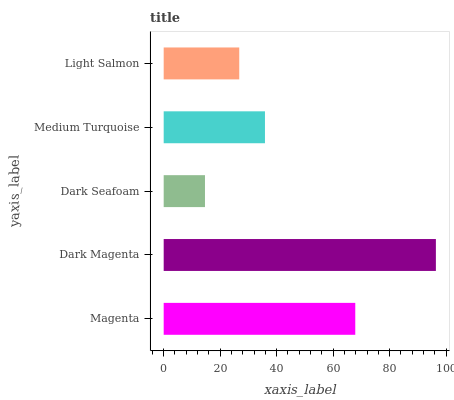Is Dark Seafoam the minimum?
Answer yes or no. Yes. Is Dark Magenta the maximum?
Answer yes or no. Yes. Is Dark Magenta the minimum?
Answer yes or no. No. Is Dark Seafoam the maximum?
Answer yes or no. No. Is Dark Magenta greater than Dark Seafoam?
Answer yes or no. Yes. Is Dark Seafoam less than Dark Magenta?
Answer yes or no. Yes. Is Dark Seafoam greater than Dark Magenta?
Answer yes or no. No. Is Dark Magenta less than Dark Seafoam?
Answer yes or no. No. Is Medium Turquoise the high median?
Answer yes or no. Yes. Is Medium Turquoise the low median?
Answer yes or no. Yes. Is Dark Magenta the high median?
Answer yes or no. No. Is Dark Seafoam the low median?
Answer yes or no. No. 